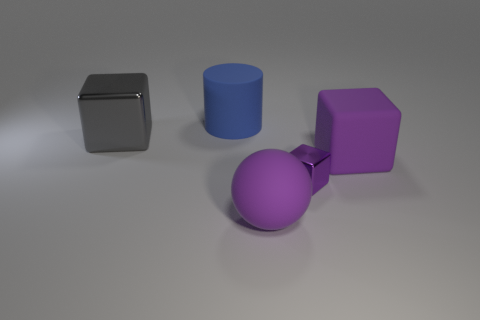There is a ball that is the same color as the small shiny block; what material is it?
Give a very brief answer. Rubber. There is a metallic block behind the purple shiny block; is its size the same as the big blue matte cylinder?
Ensure brevity in your answer.  Yes. How many big gray cubes are behind the big purple thing that is in front of the purple rubber thing that is behind the purple ball?
Provide a succinct answer. 1. What number of purple things are either big rubber balls or blocks?
Your answer should be very brief. 3. What is the color of the block that is the same material as the cylinder?
Give a very brief answer. Purple. Is there any other thing that is the same size as the purple matte ball?
Offer a terse response. Yes. What number of big things are either blocks or gray objects?
Offer a terse response. 2. Is the number of large purple spheres less than the number of rubber things?
Your answer should be very brief. Yes. What is the color of the other metallic object that is the same shape as the small metallic thing?
Give a very brief answer. Gray. Is there any other thing that is the same shape as the small shiny thing?
Make the answer very short. Yes. 